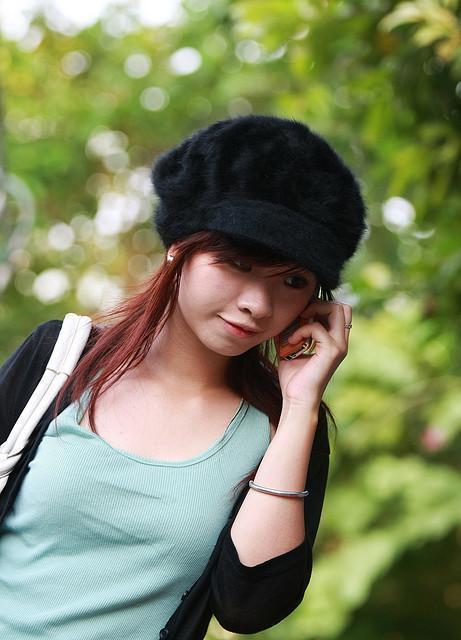Who speaks at this moment?
Select the accurate response from the four choices given to answer the question.
Options: Girl, no one, clowns, caller. Caller. 